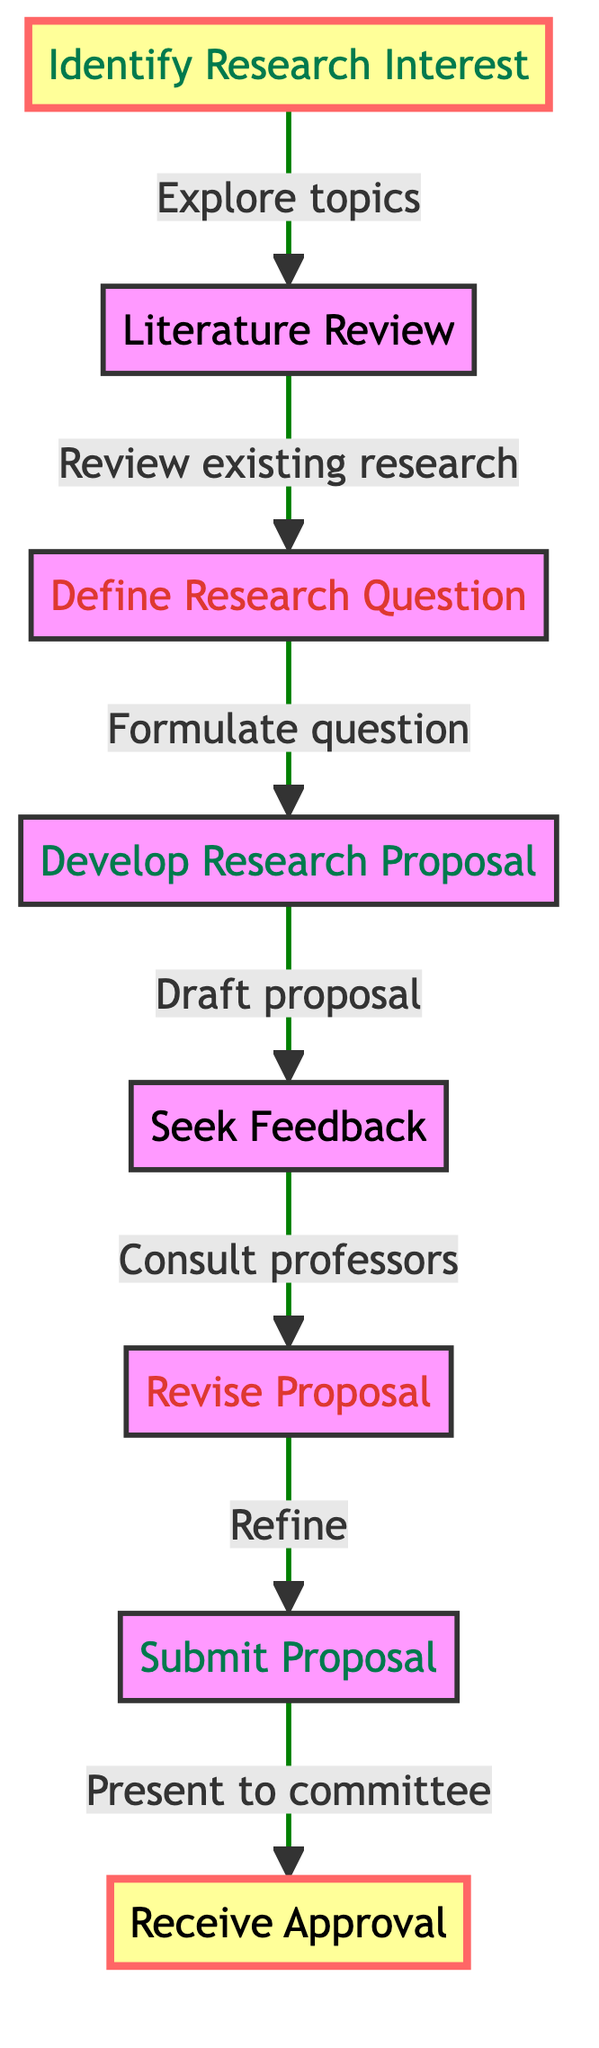What is the first step in the research proposal process? The diagram identifies "Identify Research Interest" as the first step, indicated by the starting node without any incoming edges.
Answer: Identify Research Interest How many nodes are in the flowchart? There are a total of eight nodes shown in the flowchart, each representing a distinct step in the research proposal process.
Answer: Eight What step comes immediately after the "Seek Feedback" step? The flowchart shows that "Revise Proposal" follows "Seek Feedback," indicated by a directed edge connecting these two nodes.
Answer: Revise Proposal Which step directly leads to "Submit Proposal"? The node "Revise Proposal" is the step that leads directly to "Submit Proposal," as indicated by the directed edge from "Revise Proposal" to "Submit Proposal."
Answer: Revise Proposal What is the last step of the proposal process? The final step is "Receive Approval," which concludes the flowchart. This is indicated by the last node that has no outgoing edges.
Answer: Receive Approval How many edges are directed from the "Define Research Question" step? The diagram shows that there is one directed edge from "Define Research Question" leading to "Develop Research Proposal," indicating a single relationship.
Answer: One Which two steps are highlighted in the diagram, and what does this highlight signify? "Identify Research Interest" and "Receive Approval" are highlighted, indicating they are significant starting and ending points in the research proposal process.
Answer: Identify Research Interest and Receive Approval What do students do after drafting their proposal? Students "Seek Feedback" after drafting their proposal, as indicated by the direct edge from "Develop Research Proposal" to "Seek Feedback."
Answer: Seek Feedback What should students conduct after identifying their research interest? The diagram directs students to conduct a "Literature Review" as the next step after identifying their research interest.
Answer: Literature Review 